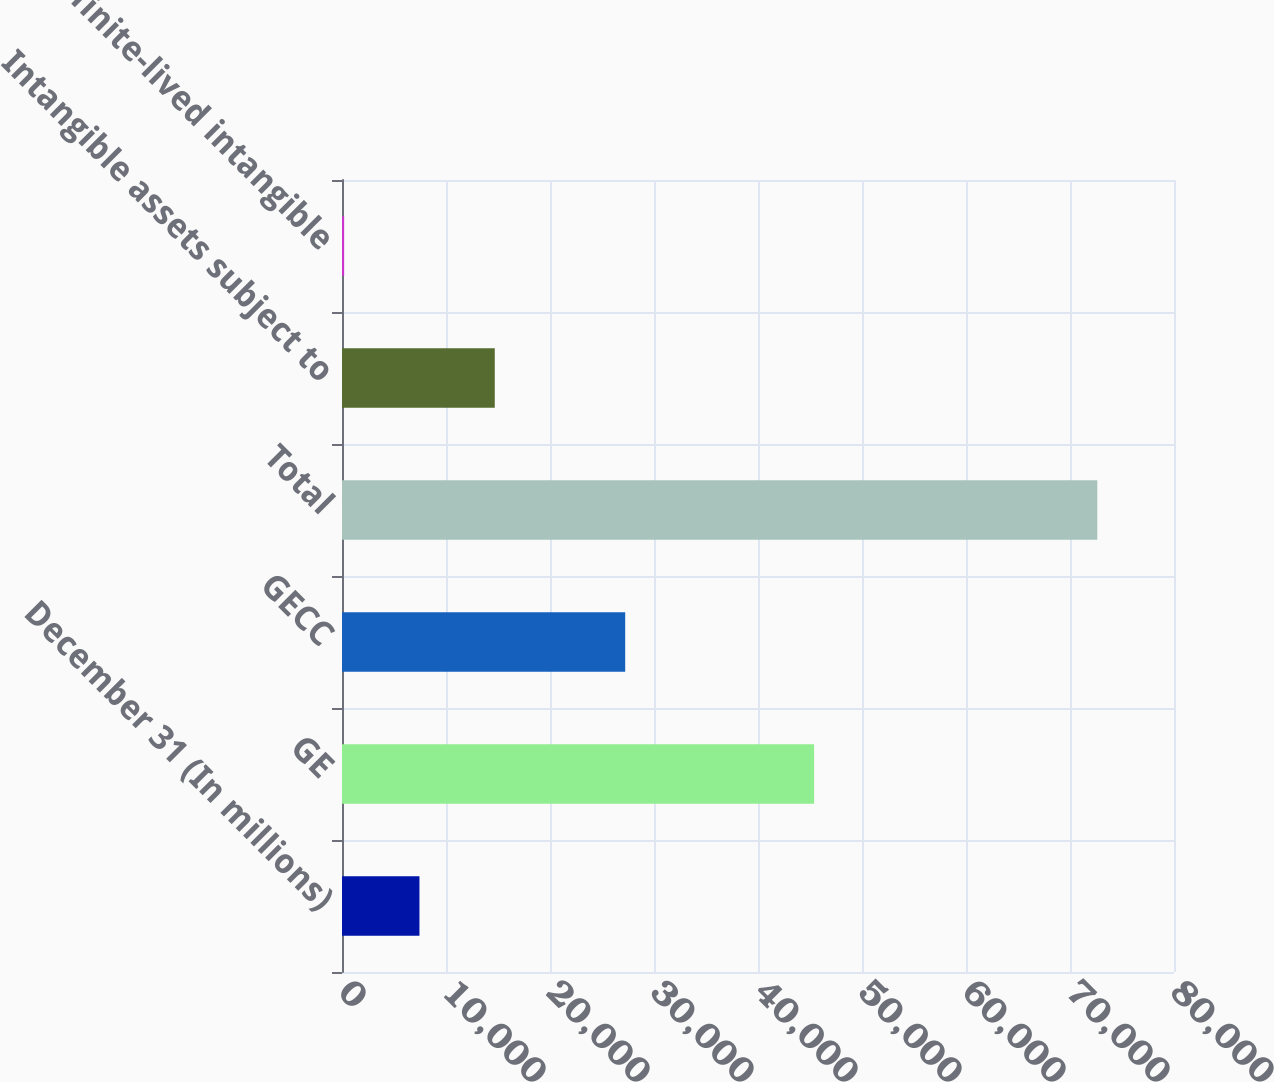<chart> <loc_0><loc_0><loc_500><loc_500><bar_chart><fcel>December 31 (In millions)<fcel>GE<fcel>GECC<fcel>Total<fcel>Intangible assets subject to<fcel>Indefinite-lived intangible<nl><fcel>7447<fcel>45395<fcel>27230<fcel>72625<fcel>14689<fcel>205<nl></chart> 